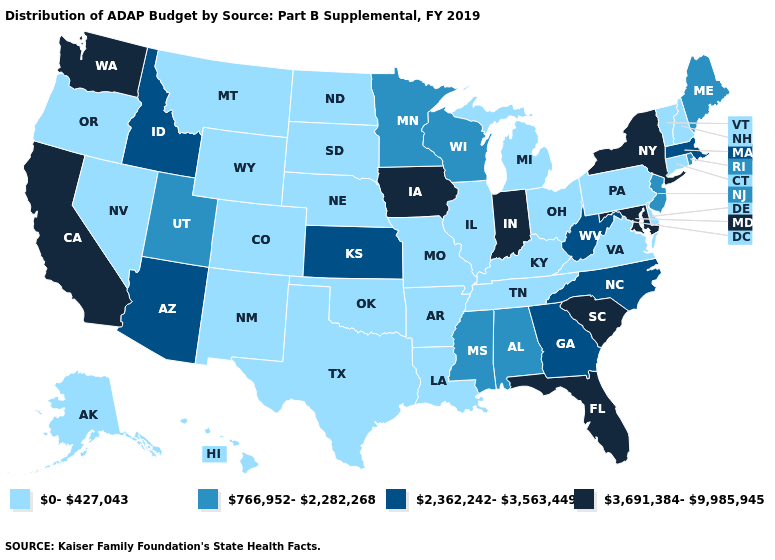What is the value of Tennessee?
Short answer required. 0-427,043. Name the states that have a value in the range 766,952-2,282,268?
Keep it brief. Alabama, Maine, Minnesota, Mississippi, New Jersey, Rhode Island, Utah, Wisconsin. What is the value of Mississippi?
Concise answer only. 766,952-2,282,268. Among the states that border New Jersey , does Pennsylvania have the highest value?
Keep it brief. No. Does Virginia have a lower value than Connecticut?
Write a very short answer. No. What is the lowest value in states that border North Dakota?
Write a very short answer. 0-427,043. Name the states that have a value in the range 0-427,043?
Write a very short answer. Alaska, Arkansas, Colorado, Connecticut, Delaware, Hawaii, Illinois, Kentucky, Louisiana, Michigan, Missouri, Montana, Nebraska, Nevada, New Hampshire, New Mexico, North Dakota, Ohio, Oklahoma, Oregon, Pennsylvania, South Dakota, Tennessee, Texas, Vermont, Virginia, Wyoming. What is the value of Mississippi?
Answer briefly. 766,952-2,282,268. Does Arizona have the lowest value in the USA?
Answer briefly. No. What is the value of Nebraska?
Quick response, please. 0-427,043. What is the lowest value in states that border Iowa?
Quick response, please. 0-427,043. Which states have the highest value in the USA?
Quick response, please. California, Florida, Indiana, Iowa, Maryland, New York, South Carolina, Washington. Name the states that have a value in the range 2,362,242-3,563,449?
Quick response, please. Arizona, Georgia, Idaho, Kansas, Massachusetts, North Carolina, West Virginia. Among the states that border Oklahoma , does Arkansas have the highest value?
Write a very short answer. No. Among the states that border North Carolina , which have the highest value?
Write a very short answer. South Carolina. 